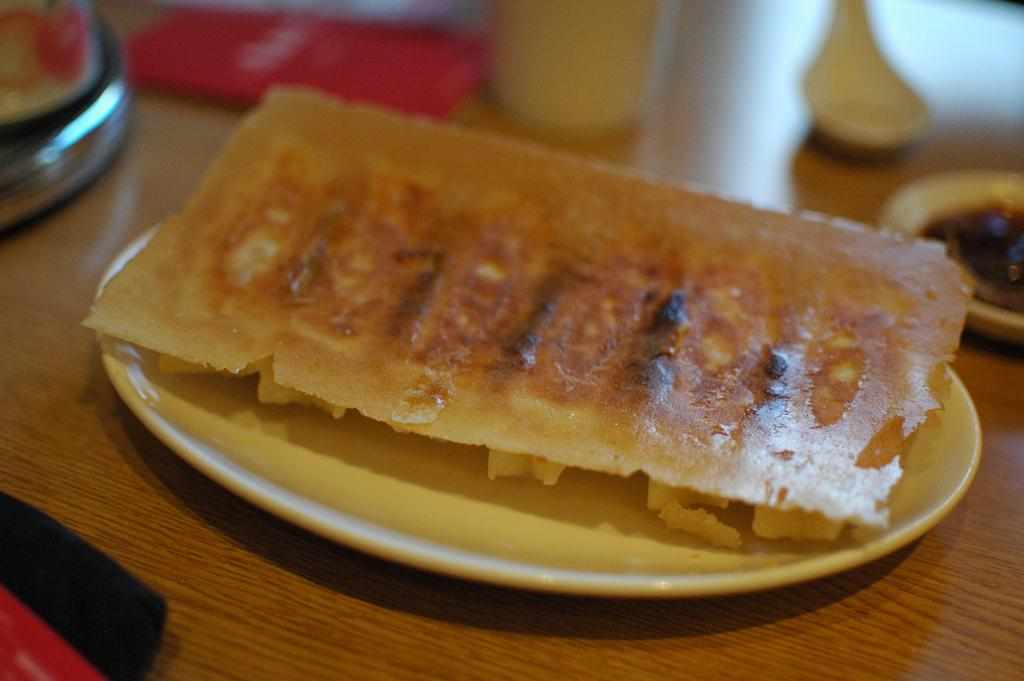What objects are present in the image that are typically used for eating? There are plates and spoons in the image that are typically used for eating. What else can be seen in the image besides plates and spoons? There is food in the image. What type of surface is the food and utensils placed on? There is a wooden platform in the image. How many cards are visible on the wooden platform in the image? There are no cards present in the image; only plates, spoons, and food can be seen. Can you describe the ducks that are swimming in the food in the image? There are no ducks present in the image; the food is not depicted as containing any animals. 